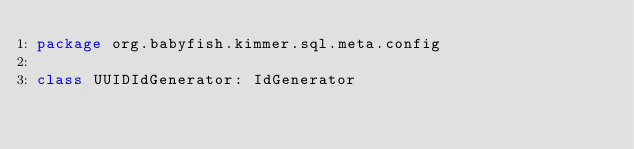<code> <loc_0><loc_0><loc_500><loc_500><_Kotlin_>package org.babyfish.kimmer.sql.meta.config

class UUIDIdGenerator: IdGenerator</code> 